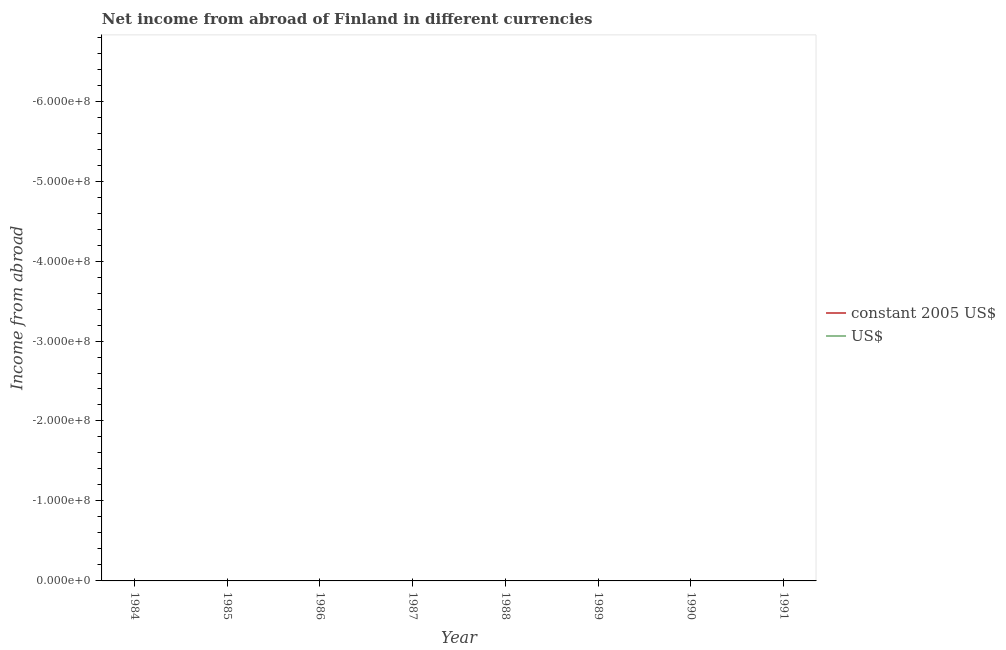Does the line corresponding to income from abroad in us$ intersect with the line corresponding to income from abroad in constant 2005 us$?
Give a very brief answer. Yes. Across all years, what is the minimum income from abroad in us$?
Keep it short and to the point. 0. In how many years, is the income from abroad in constant 2005 us$ greater than -400000000 units?
Keep it short and to the point. 0. In how many years, is the income from abroad in constant 2005 us$ greater than the average income from abroad in constant 2005 us$ taken over all years?
Offer a terse response. 0. Does the income from abroad in constant 2005 us$ monotonically increase over the years?
Offer a very short reply. No. How many lines are there?
Ensure brevity in your answer.  0. How many years are there in the graph?
Offer a terse response. 8. What is the difference between two consecutive major ticks on the Y-axis?
Offer a very short reply. 1.00e+08. Are the values on the major ticks of Y-axis written in scientific E-notation?
Ensure brevity in your answer.  Yes. Does the graph contain grids?
Offer a terse response. No. What is the title of the graph?
Keep it short and to the point. Net income from abroad of Finland in different currencies. Does "GDP" appear as one of the legend labels in the graph?
Offer a terse response. No. What is the label or title of the X-axis?
Provide a succinct answer. Year. What is the label or title of the Y-axis?
Your answer should be very brief. Income from abroad. What is the Income from abroad in constant 2005 US$ in 1984?
Your answer should be compact. 0. What is the Income from abroad in constant 2005 US$ in 1986?
Your answer should be compact. 0. What is the Income from abroad in constant 2005 US$ in 1989?
Your answer should be compact. 0. What is the Income from abroad of US$ in 1989?
Provide a succinct answer. 0. What is the Income from abroad of constant 2005 US$ in 1990?
Your answer should be very brief. 0. What is the Income from abroad of constant 2005 US$ in 1991?
Ensure brevity in your answer.  0. What is the Income from abroad of US$ in 1991?
Offer a very short reply. 0. What is the total Income from abroad of constant 2005 US$ in the graph?
Provide a short and direct response. 0. What is the average Income from abroad of US$ per year?
Offer a terse response. 0. 